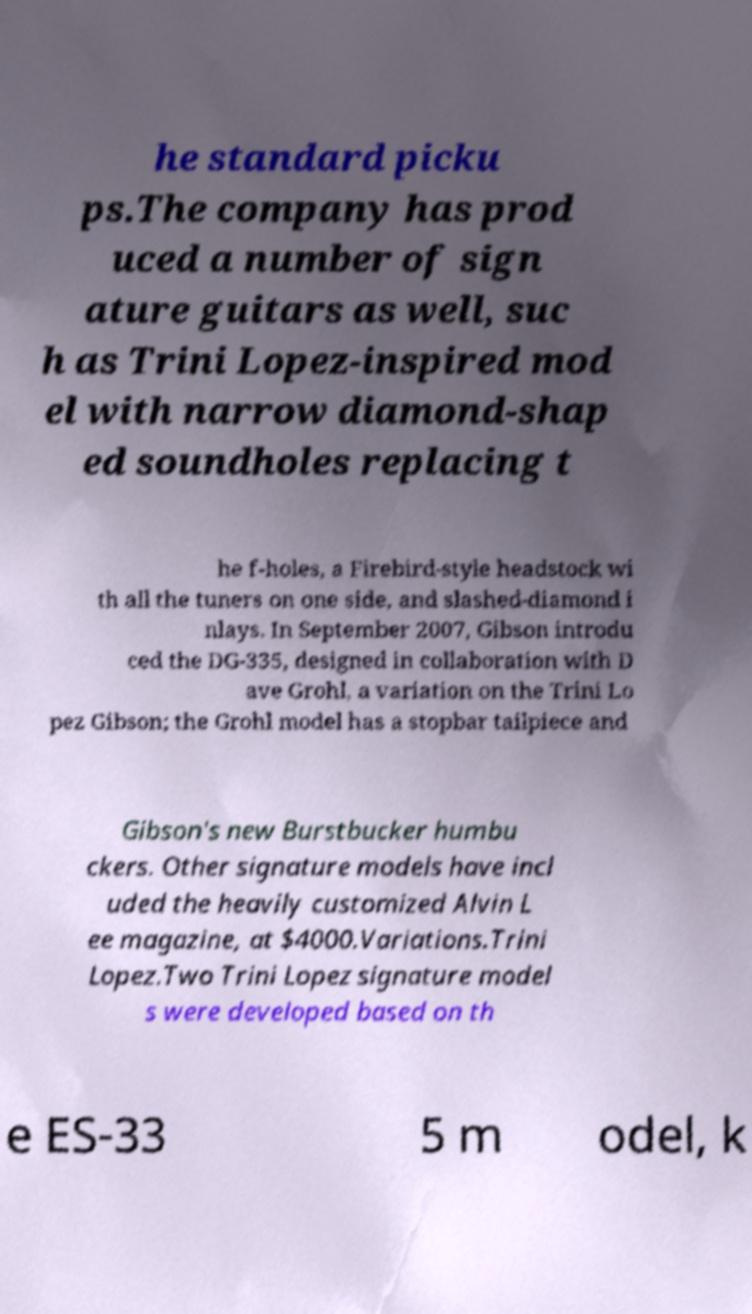Could you assist in decoding the text presented in this image and type it out clearly? he standard picku ps.The company has prod uced a number of sign ature guitars as well, suc h as Trini Lopez-inspired mod el with narrow diamond-shap ed soundholes replacing t he f-holes, a Firebird-style headstock wi th all the tuners on one side, and slashed-diamond i nlays. In September 2007, Gibson introdu ced the DG-335, designed in collaboration with D ave Grohl, a variation on the Trini Lo pez Gibson; the Grohl model has a stopbar tailpiece and Gibson's new Burstbucker humbu ckers. Other signature models have incl uded the heavily customized Alvin L ee magazine, at $4000.Variations.Trini Lopez.Two Trini Lopez signature model s were developed based on th e ES-33 5 m odel, k 